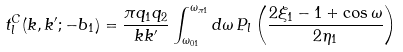<formula> <loc_0><loc_0><loc_500><loc_500>t ^ { C } _ { l } ( k , k ^ { \prime } ; - b _ { 1 } ) = \frac { \pi q _ { 1 } q _ { 2 } } { k k ^ { \prime } } \int _ { \omega _ { 0 1 } } ^ { \omega _ { \pi 1 } } d \omega \, P _ { l } \left ( \frac { 2 \xi _ { 1 } - 1 + \cos \omega } { 2 \eta _ { 1 } } \right )</formula> 